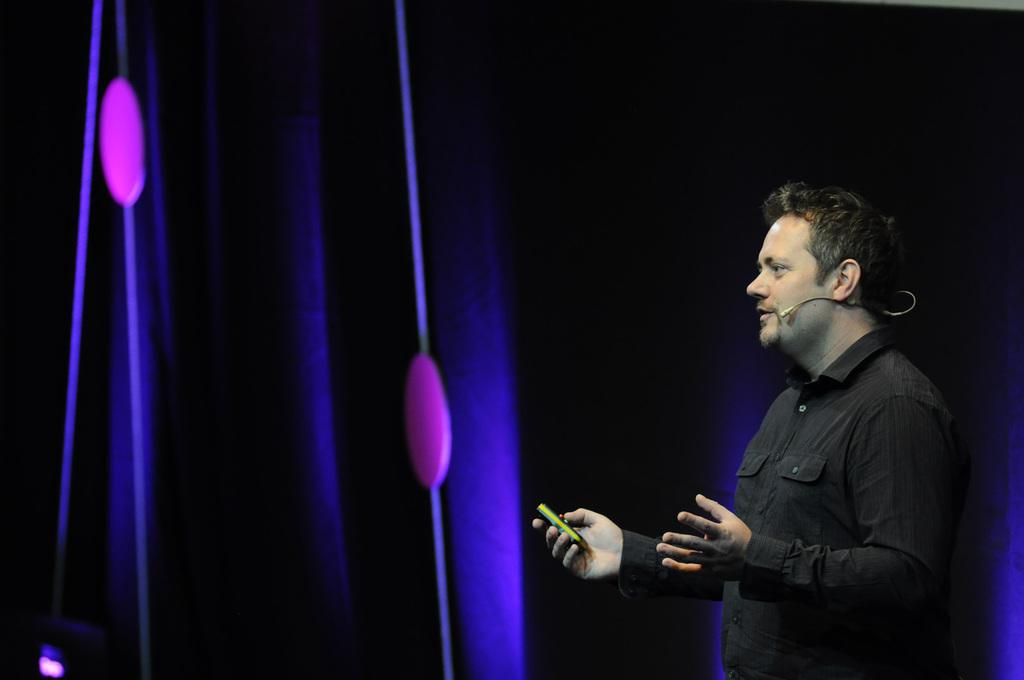What is the man in the image doing? The man is talking on a microphone. What is the man wearing in the image? The man is wearing a black t-shirt. What object is the man holding in the image? The man is holding a remote. What can be seen on the wall in the background of the image? There are lights on the wall in the background of the image. What type of baseball play is the man discussing on the microphone? There is no mention of baseball in the image, and the man is not discussing any specific play. 